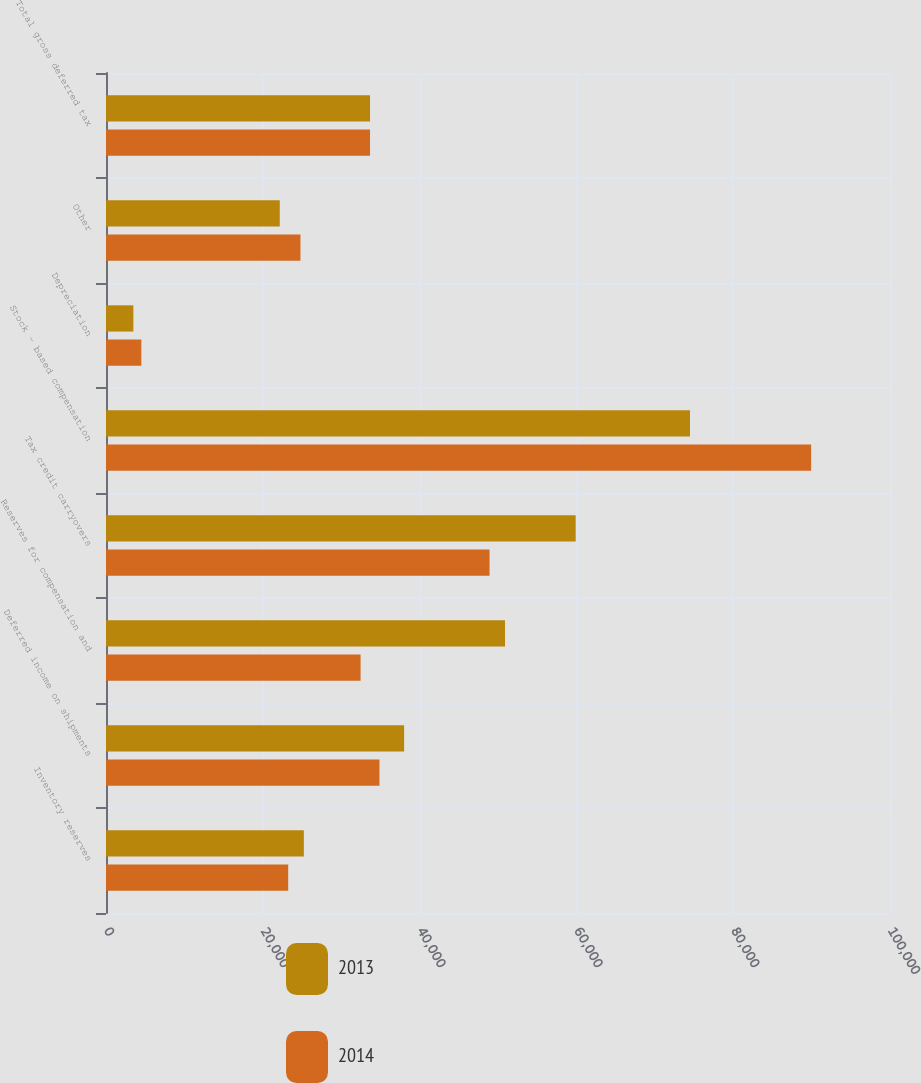Convert chart. <chart><loc_0><loc_0><loc_500><loc_500><stacked_bar_chart><ecel><fcel>Inventory reserves<fcel>Deferred income on shipments<fcel>Reserves for compensation and<fcel>Tax credit carryovers<fcel>Stock - based compensation<fcel>Depreciation<fcel>Other<fcel>Total gross deferred tax<nl><fcel>2013<fcel>25236<fcel>38025<fcel>50895<fcel>59909<fcel>74487<fcel>3490<fcel>22165<fcel>33677.5<nl><fcel>2014<fcel>23238<fcel>34882<fcel>32473<fcel>48920<fcel>89944<fcel>4507<fcel>24803<fcel>33677.5<nl></chart> 